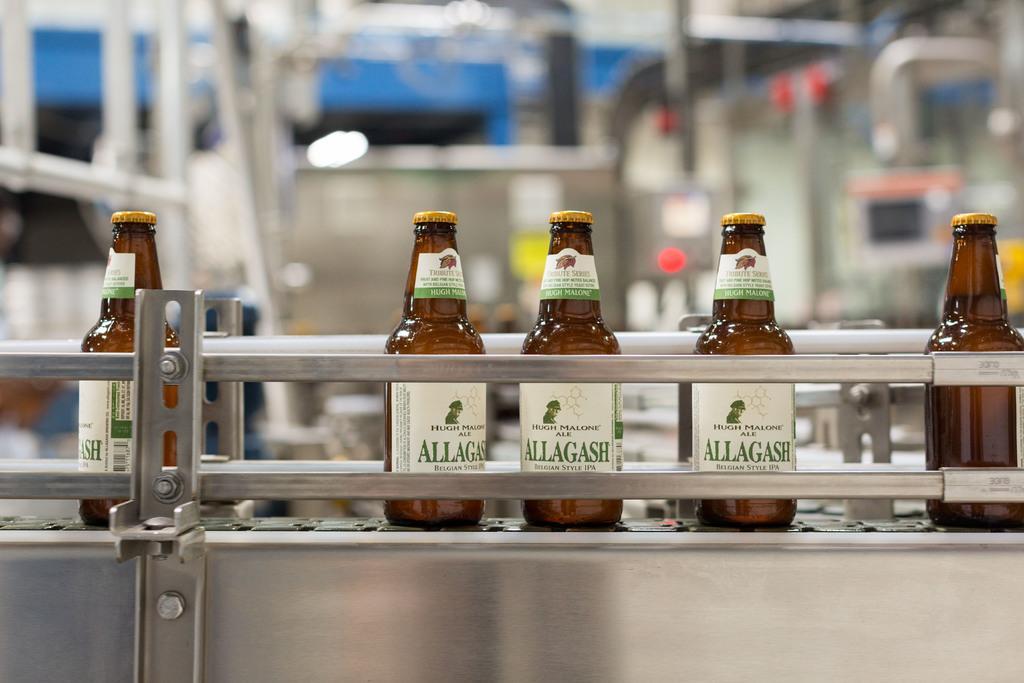How would you summarize this image in a sentence or two? In this picture there are beer bottles and there is some machinery in the background 